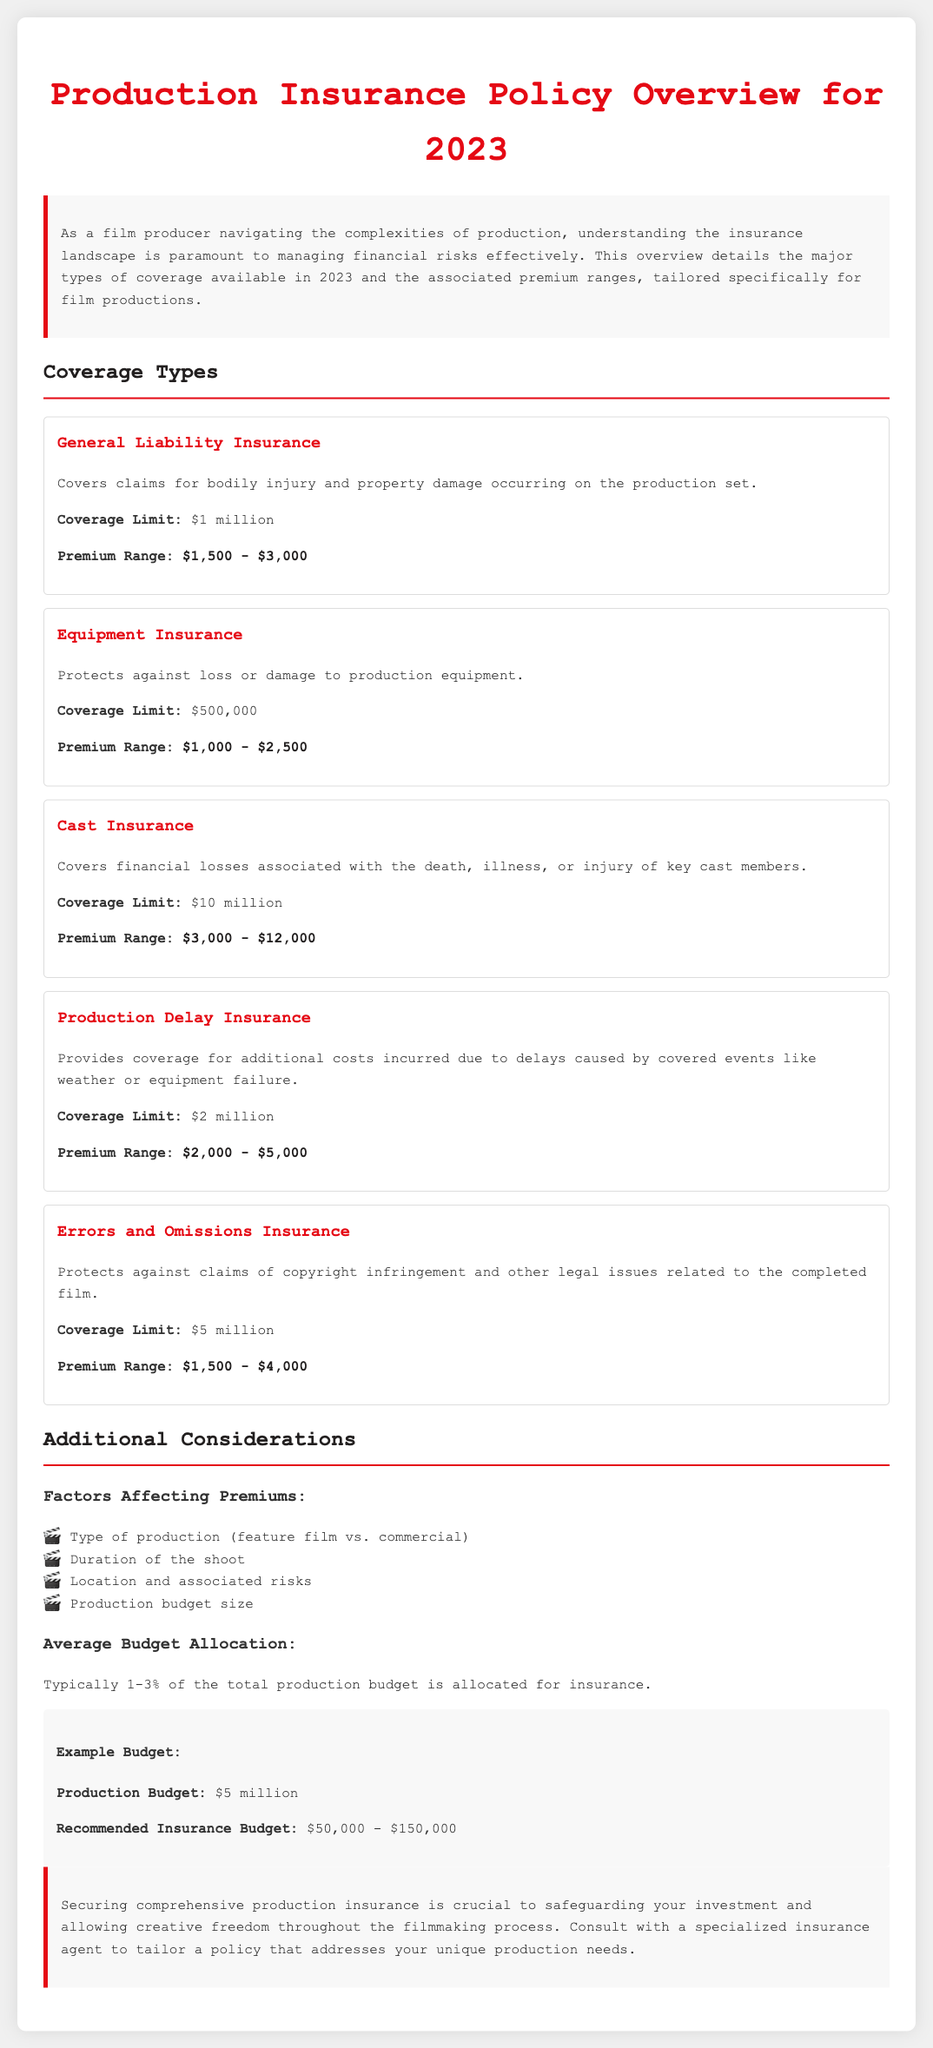what is the coverage limit for General Liability Insurance? The coverage limit for General Liability Insurance is specified in the document as $1 million.
Answer: $1 million what is the premium range for Cast Insurance? The document states that the premium range for Cast Insurance is between $3,000 and $12,000.
Answer: $3,000 - $12,000 what percentage of the production budget is typically allocated for insurance? The document indicates that typically 1-3% of the total production budget is allocated for insurance.
Answer: 1-3% how much is the coverage limit for Equipment Insurance? The coverage limit for Equipment Insurance is mentioned as $500,000 in the document.
Answer: $500,000 what is the coverage for Production Delay Insurance? The document describes Production Delay Insurance as providing coverage for additional costs due to delays caused by covered events.
Answer: Additional costs due to delays what factors affect premiums according to the document? The factors affecting premiums include the type of production, duration of the shoot, location and associated risks, and production budget size.
Answer: Type of production, duration, location, budget size what is the recommended insurance budget for a $5 million production? The document advises a recommended insurance budget in the range of $50,000 to $150,000 for a $5 million production.
Answer: $50,000 - $150,000 what type of claims does Errors and Omissions Insurance protect against? Errors and Omissions Insurance protects against claims of copyright infringement and other legal issues related to the completed film as stated in the document.
Answer: Copyright infringement claims what is the coverage limit for Production Delay Insurance? The coverage limit for Production Delay Insurance is indicated as $2 million in the document.
Answer: $2 million what is the primary purpose of securing comprehensive production insurance? The document states that securing comprehensive production insurance is crucial to safeguarding your investment.
Answer: Safeguarding your investment 